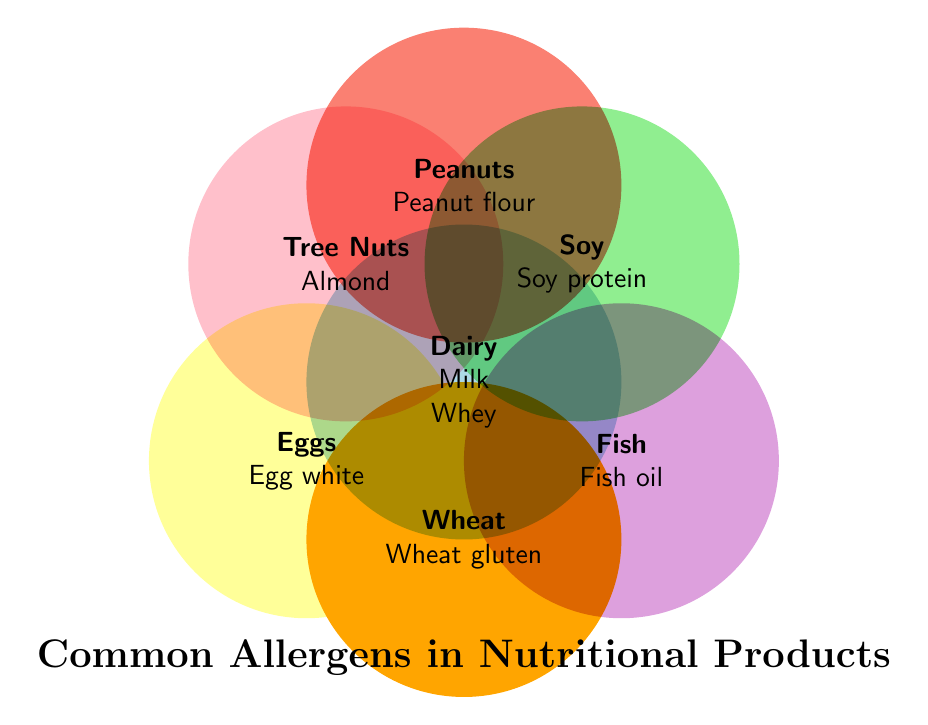What is the title of the figure? The title is typically displayed prominently and can be found at the top or bottom of the figure. In this case, it is at the bottom and reads "Common Allergens in Nutritional Products."
Answer: Common Allergens in Nutritional Products Which allergen is shown in the Dairy section? To find which allergens are in the Dairy section, look at the list under the "Dairy" category in the Venn diagram.
Answer: Milk, Whey, Casein Are there any allergens listed for Eggs? Check the section labeled "Eggs" to identify any allergens associated with it.
Answer: Egg white, Egg albumin How many allergens are listed in the Fish category? Count the items under the "Fish" section in the Venn diagram.
Answer: Two Which categories overlap in the Venn diagram? Identify sections where circles overlap; however, note that in this case, the Venn diagram provided does not show overlaps among categories.
Answer: None Which category has more allergens: Wheat or Tree Nuts? Compare the number of allergens listed under the "Wheat" and "Tree Nuts" sections. Wheat has Wheat gluten and Wheat bran, while Tree Nuts have Almond and Macadamia.
Answer: Equal How many allergens are there in total in the Venn diagram? Sum the allergens listed in all categories: 3 (Dairy) + 2 (Soy) + 2 (Tree Nuts) + 2 (Eggs) + 2 (Wheat) + 2 (Fish) + 2 (Peanuts).
Answer: 15 Name an allergen found in the Soy category. Look at the items listed under the "Soy" section.
Answer: Soy protein, Soy lecithin What color represents the Dairy category in the Venn diagram? The color representing the Dairy category can be identified by looking at the section labeled "Dairy."
Answer: Light blue Is Peanut protein included in the list? If so, which category? Check all the categories for "Peanut protein." You will find it under the "Peanuts" category.
Answer: Yes, Peanuts 